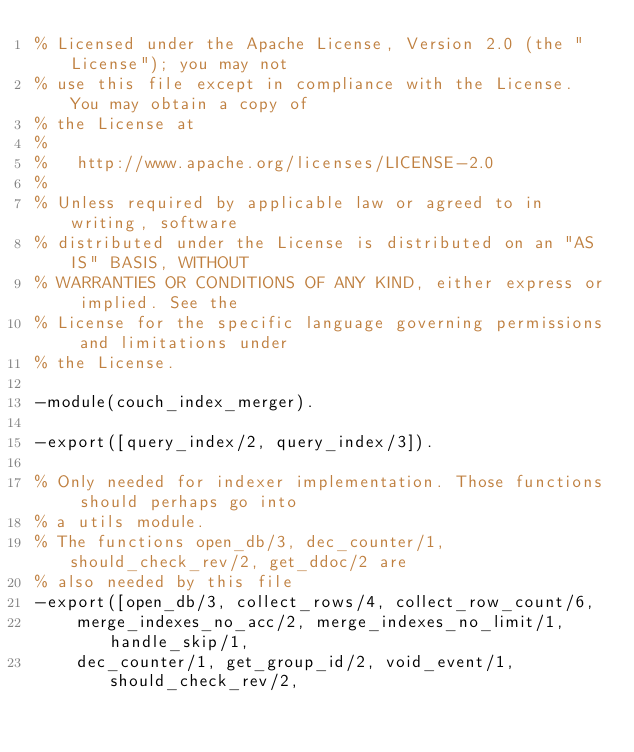Convert code to text. <code><loc_0><loc_0><loc_500><loc_500><_Erlang_>% Licensed under the Apache License, Version 2.0 (the "License"); you may not
% use this file except in compliance with the License. You may obtain a copy of
% the License at
%
%   http://www.apache.org/licenses/LICENSE-2.0
%
% Unless required by applicable law or agreed to in writing, software
% distributed under the License is distributed on an "AS IS" BASIS, WITHOUT
% WARRANTIES OR CONDITIONS OF ANY KIND, either express or implied. See the
% License for the specific language governing permissions and limitations under
% the License.

-module(couch_index_merger).

-export([query_index/2, query_index/3]).

% Only needed for indexer implementation. Those functions should perhaps go into
% a utils module.
% The functions open_db/3, dec_counter/1, should_check_rev/2, get_ddoc/2 are
% also needed by this file
-export([open_db/3, collect_rows/4, collect_row_count/6,
    merge_indexes_no_acc/2, merge_indexes_no_limit/1, handle_skip/1,
    dec_counter/1, get_group_id/2, void_event/1, should_check_rev/2,</code> 